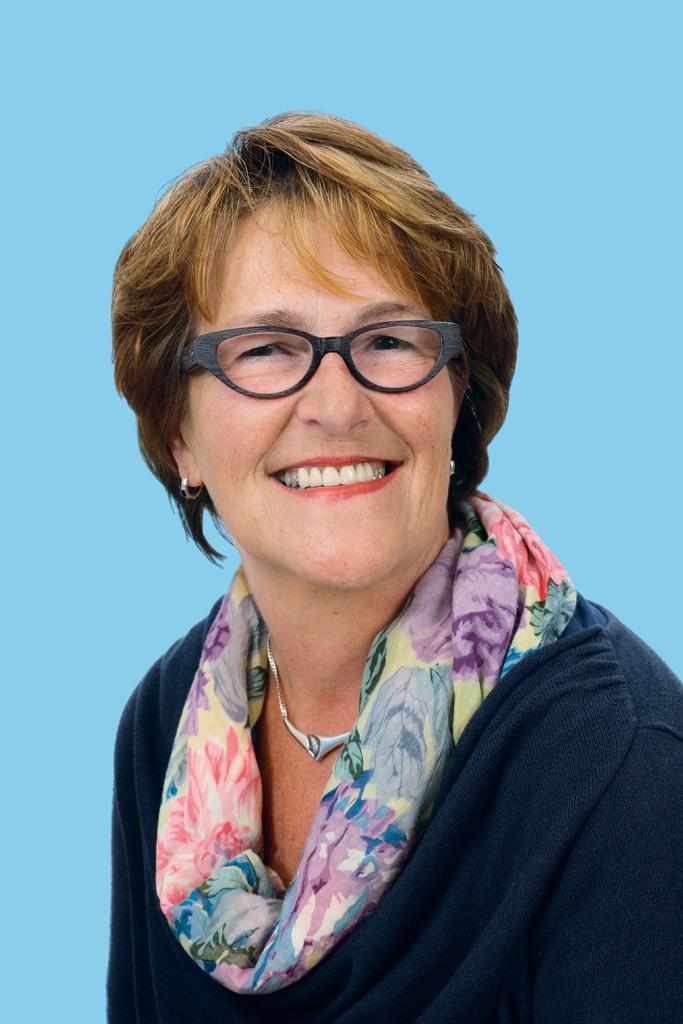Please provide a concise description of this image. In this image, we can see a woman is smiling and wearing glasses and scarf. Background we can see blue color. 